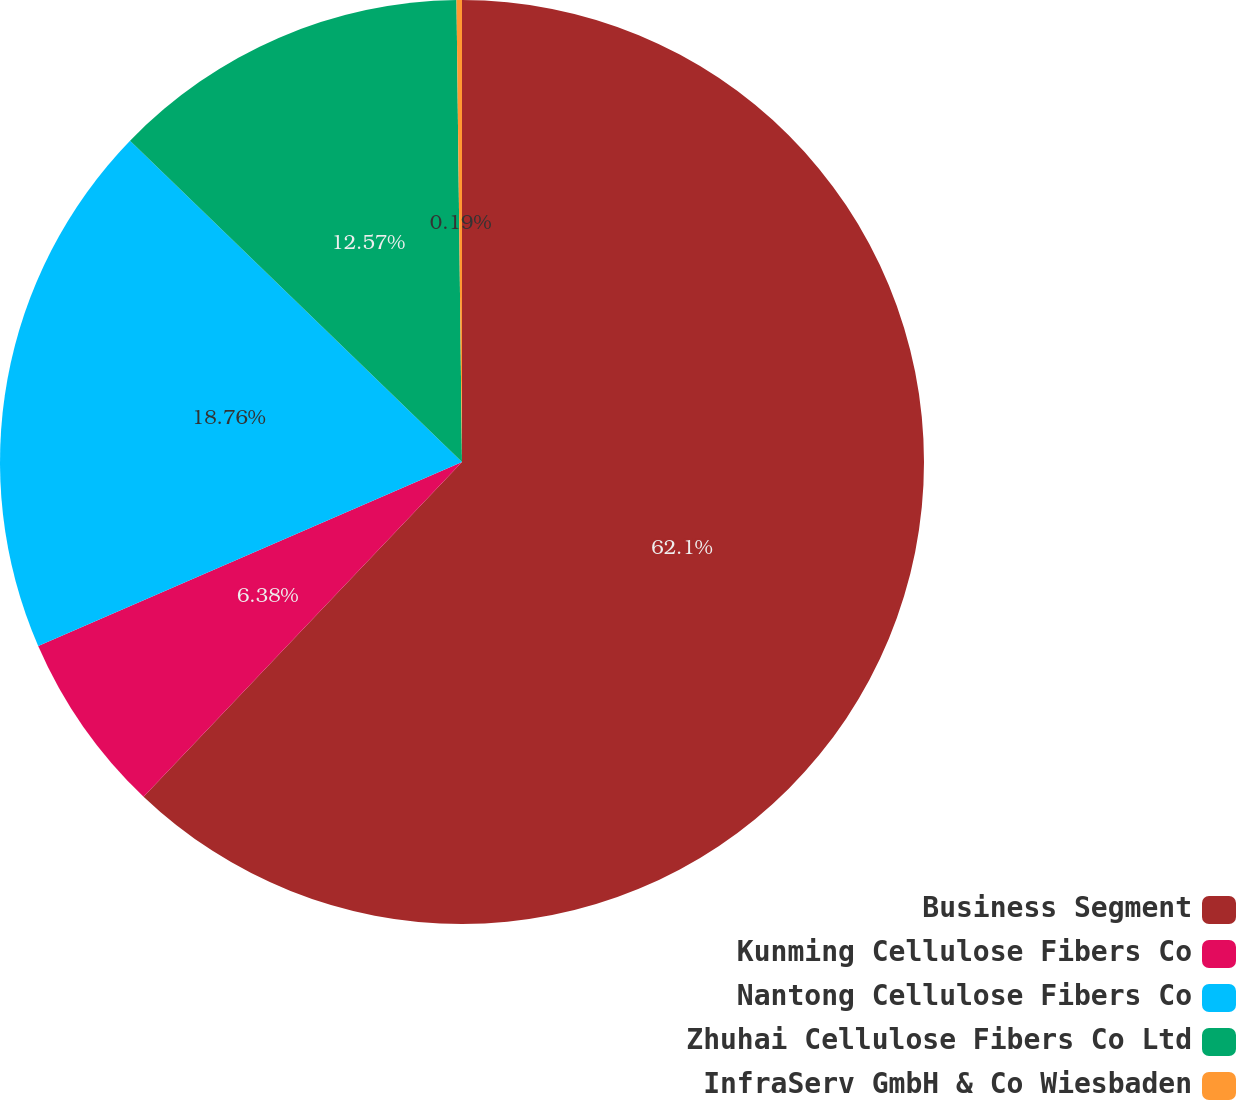<chart> <loc_0><loc_0><loc_500><loc_500><pie_chart><fcel>Business Segment<fcel>Kunming Cellulose Fibers Co<fcel>Nantong Cellulose Fibers Co<fcel>Zhuhai Cellulose Fibers Co Ltd<fcel>InfraServ GmbH & Co Wiesbaden<nl><fcel>62.11%<fcel>6.38%<fcel>18.76%<fcel>12.57%<fcel>0.19%<nl></chart> 